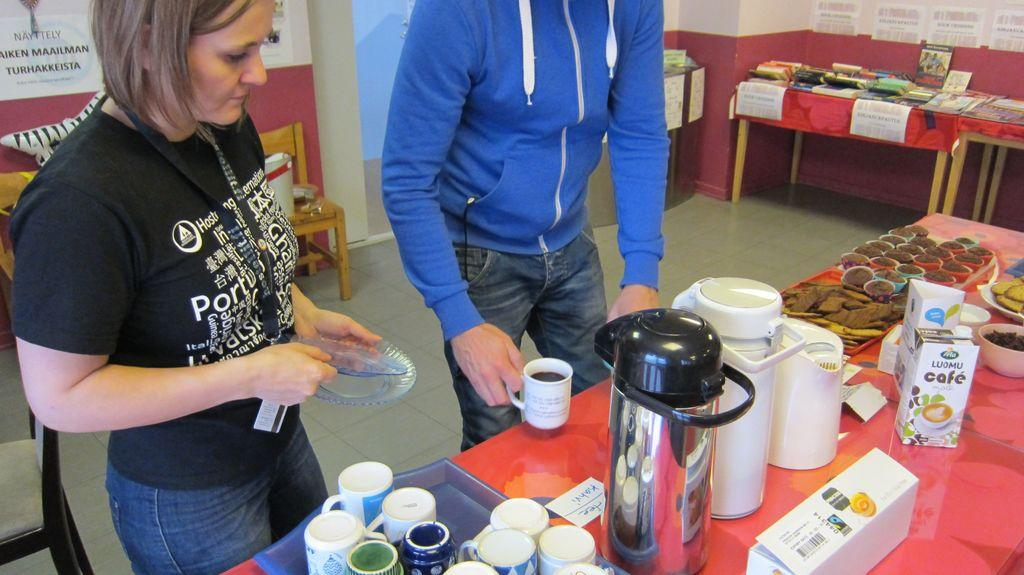<image>
Create a compact narrative representing the image presented. Two people getting coffee and snacks at a table that has a box of Luomu cafe creamer. 